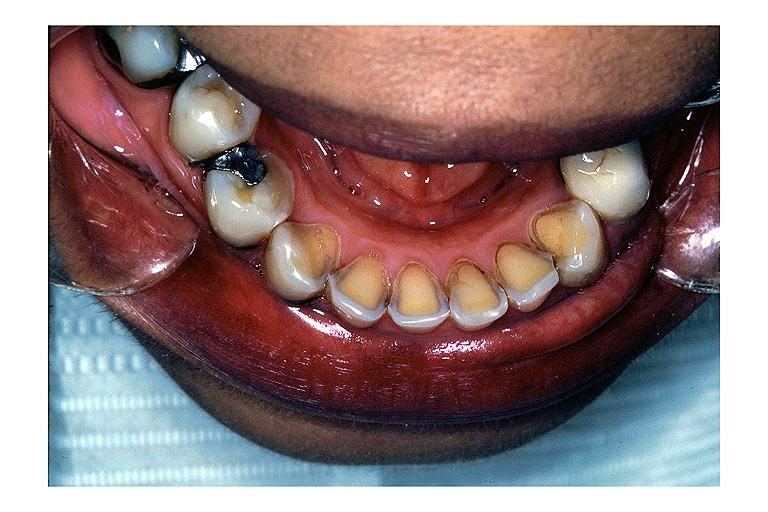where is this?
Answer the question using a single word or phrase. Oral 